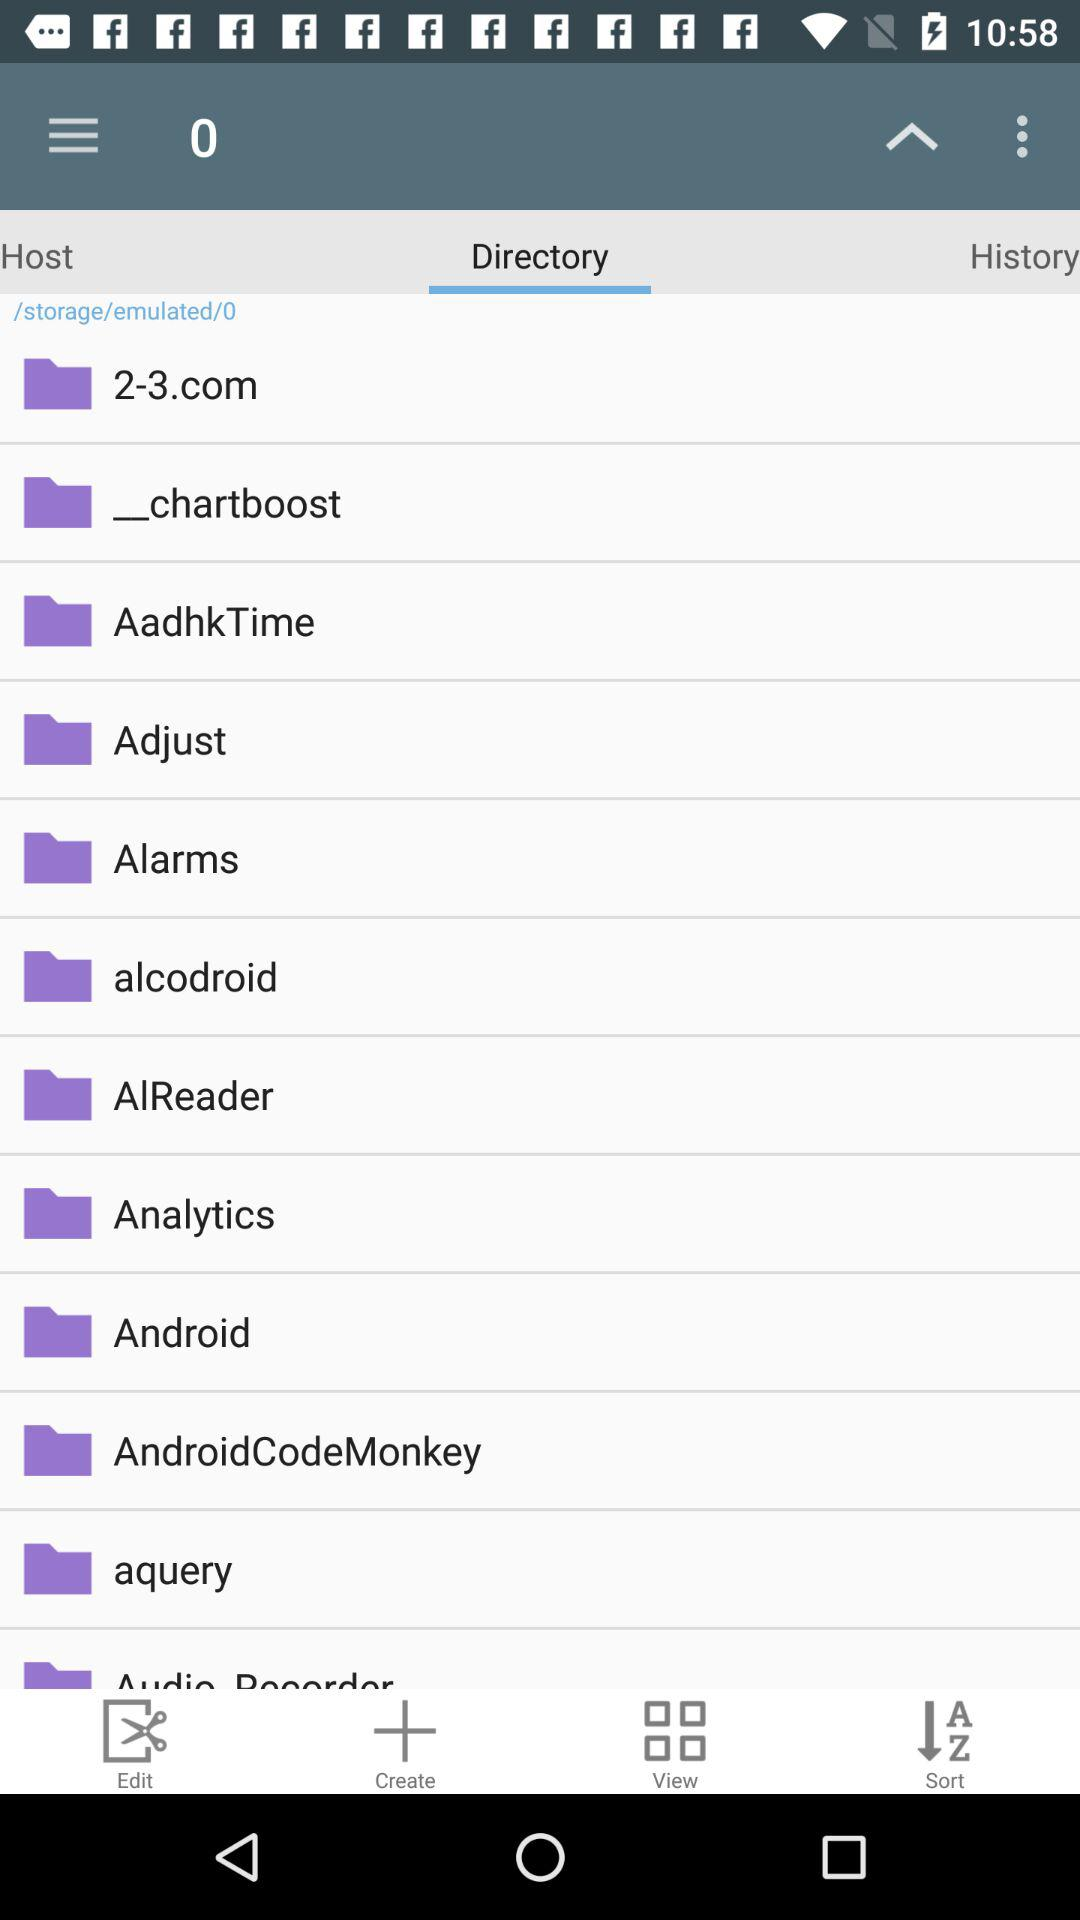Which tab is selected? The selected tab is "Directory". 